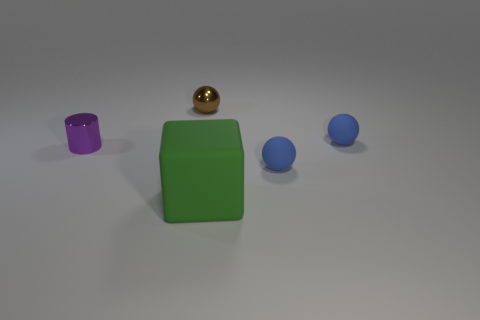How many objects are either balls on the left side of the large rubber thing or balls?
Offer a terse response. 3. What material is the small brown ball behind the tiny shiny cylinder?
Provide a short and direct response. Metal. What material is the green block?
Your answer should be compact. Rubber. There is a small brown thing that is to the right of the thing that is on the left side of the sphere that is left of the block; what is it made of?
Give a very brief answer. Metal. Do the green matte object and the shiny sphere that is behind the purple shiny cylinder have the same size?
Ensure brevity in your answer.  No. What number of objects are either matte things that are to the right of the brown shiny ball or tiny spheres on the left side of the large rubber cube?
Your answer should be very brief. 4. The tiny thing in front of the purple metal thing is what color?
Provide a succinct answer. Blue. There is a blue ball behind the small purple shiny cylinder; is there a matte sphere in front of it?
Give a very brief answer. Yes. Are there fewer tiny shiny balls than metal objects?
Provide a succinct answer. Yes. The brown thing that is to the left of the matte ball in front of the cylinder is made of what material?
Your response must be concise. Metal. 